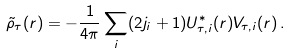<formula> <loc_0><loc_0><loc_500><loc_500>\tilde { \rho } _ { \tau } ( r ) = - \frac { 1 } { 4 \pi } \sum _ { i } ( 2 j _ { i } + 1 ) U _ { \tau , i } ^ { * } ( r ) V _ { \tau , i } ( r ) \, .</formula> 